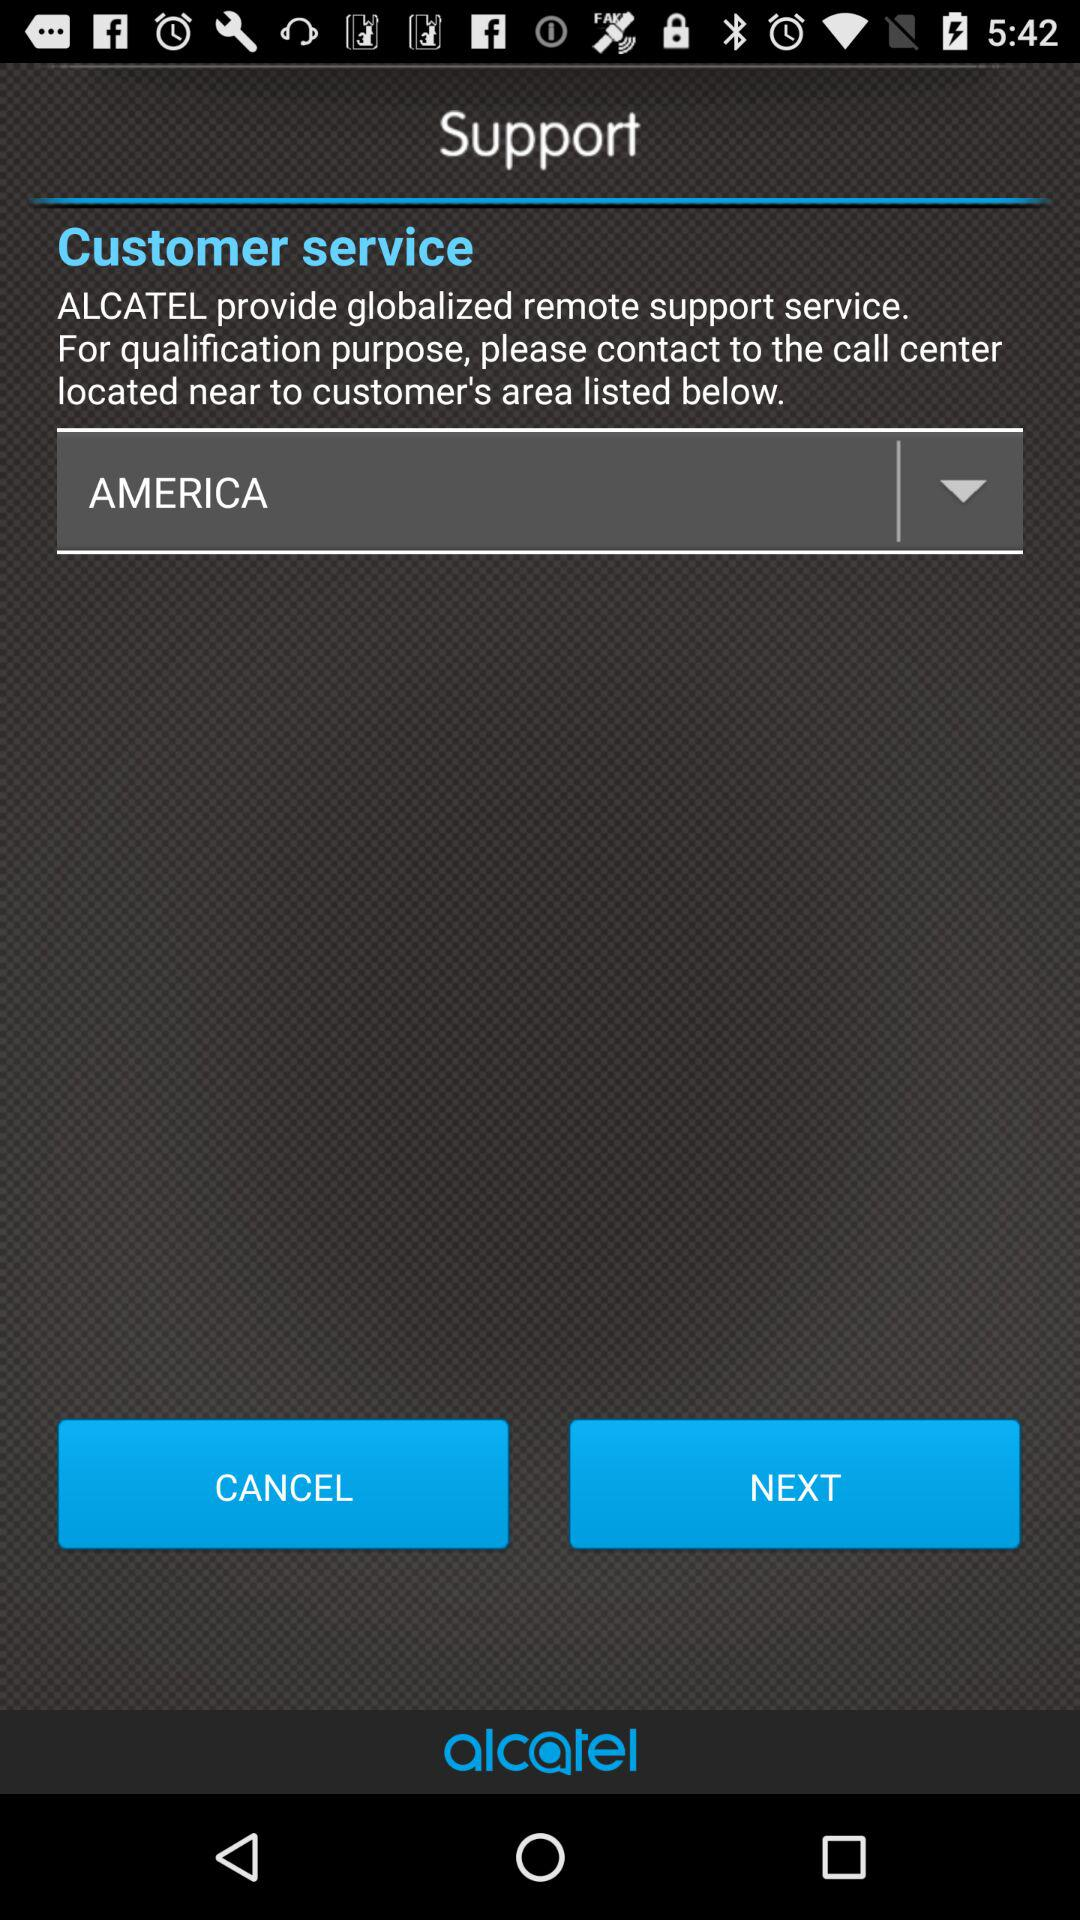What is the application name? The application name is "ALCATEL". 